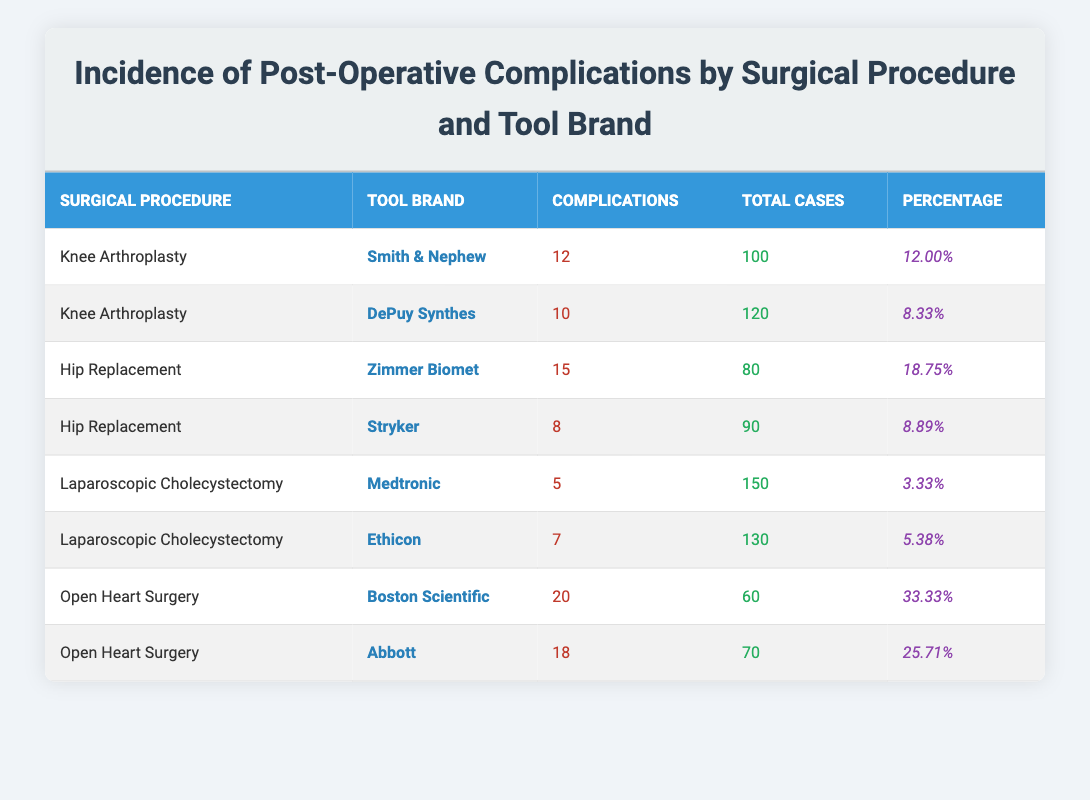What is the percentage of postoperative complications for Knee Arthroplasty with Smith & Nephew tools? The table shows that there were 12 postoperative complications out of 100 total cases for Knee Arthroplasty using Smith & Nephew tools. To calculate the percentage, we use the formula: (12 / 100) * 100 = 12.00%.
Answer: 12.00% Which tool brand had the highest incidence of postoperative complications in Hip Replacement? By comparing the percentages of complications in the Hip Replacement category, Zimmer Biomet has 18.75% complications while Stryker has 8.89%. Therefore, Zimmer Biomet has the highest incidence.
Answer: Zimmer Biomet Is the incidence of complications higher with Abbott tools compared to Medtronic tools? Abbott tools had 25.71% complications while Medtronic tools had only 3.33%. Since 25.71% is greater than 3.33%, the statement is true.
Answer: Yes What is the average percentage of postoperative complications across all surgical procedures in this table? To find the average, we add the percentage values: 12.00% + 8.33% + 18.75% + 8.89% + 3.33% + 5.38% + 33.33% + 25.71% = 116.71%. We then divide by 8 (the number of procedures), which gives an average of 14.59%.
Answer: 14.59% How many total cases were there for all types of surgical procedures combined? By summing the total cases from each procedure: 100 + 120 + 80 + 90 + 150 + 130 + 60 + 70 = 900. Thus, the total cases across all procedures is 900.
Answer: 900 Which tool brand had the lowest incidence of postoperative complications in Laparoscopic Cholecystectomy? Looking at the Laparoscopic Cholecystectomy tools, Medtronic had 3.33% while Ethicon had 5.38%. Since 3.33% is lower than 5.38%, Medtronic had the lowest incidence.
Answer: Medtronic Is it true that Smith & Nephew tool brand has more complications in Knee Arthroplasty than Stryker in Hip Replacement? Smith & Nephew has 12 complications (12.00%) while Stryker has only 8 complications (8.89%). Since 12.00% is greater than 8.89%, the statement is true.
Answer: Yes What is the difference in complications between Open Heart Surgery using Boston Scientific and Abbott? Boston Scientific has 20 complications while Abbott has 18. Therefore, the difference in the number of complications is 20 - 18 = 2.
Answer: 2 